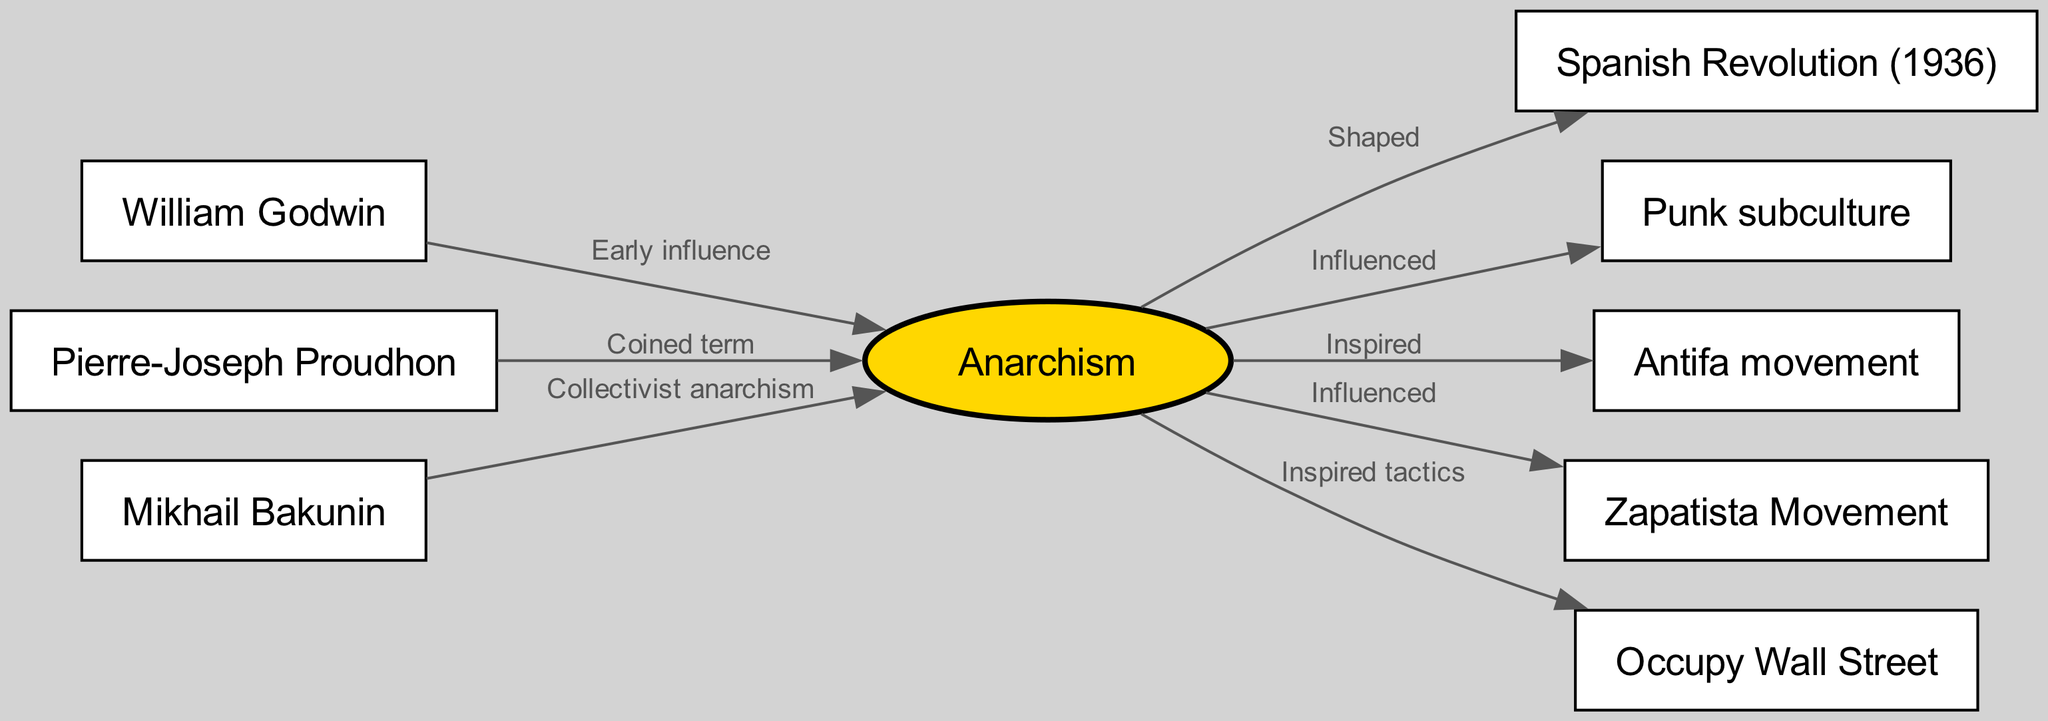What is the primary node in this diagram? The primary node is the central concept of the diagram; all other nodes connect to it to illustrate their relationship to this concept. In this case, the node labeled "Anarchism" serves as the central theme.
Answer: Anarchism How many edges connect to the "anarchism" node? To determine this, we count all outgoing connections from the "anarchism" node. The diagram shows four edges leading from the anarchism node to other nodes, indicating direct relationships.
Answer: 4 Who coined the term "anarchism"? The relationship indicating the origin of the term is represented in the diagram, where the label 'Coined term' is directly connecting the node "Proudhon" to the node "Anarchism". This indicates that the connection signifies his contribution to the terminology.
Answer: Pierre-Joseph Proudhon Which movement is shown as being shaped by anarchism? The diagram presents a direct edge from the "anarchism" node to the "Spanish Revolution (1936)" node, clearly indicating a significant influence of anarchism on this historical event, which is described by the label 'Shaped'.
Answer: Spanish Revolution (1936) How does the punk subculture connect to anarchism? Observing the diagram indicates a connection labeled 'Influenced' that goes from the anarchism node to the punk subculture node, illustrating the influence of anarchist ideas on this cultural movement.
Answer: Influenced What type of anarchism is represented by Mikhail Bakunin? The specific contribution of Bakunin to anarchism is noted by the connection labeled 'Collectivist anarchism' indicating his specific ideological stance within a larger tradition of anarchism.
Answer: Collectivist anarchism How many total nodes are present in the diagram? By counting all unique nodes in the diagram, we can determine the total number of concepts being represented. There are eight nodes listed, representing various aspects and movements related to anarchism.
Answer: 8 Which modern movement is depicted as inspired by tactics from anarchism? The diagram shows a relationship indicating that the "Occupy Wall Street" movement drew inspiration from anarchist methods, as noted by the label 'Inspired tactics' connected to the anarchism node.
Answer: Occupy Wall Street What was the role of William Godwin in relation to anarchism? Godwin's connection to anarchism is labeled 'Early influence', demonstrating that he played a foundational role in shaping early anarchist thought, and his ideas contributed to later developments in the movement.
Answer: Early influence 